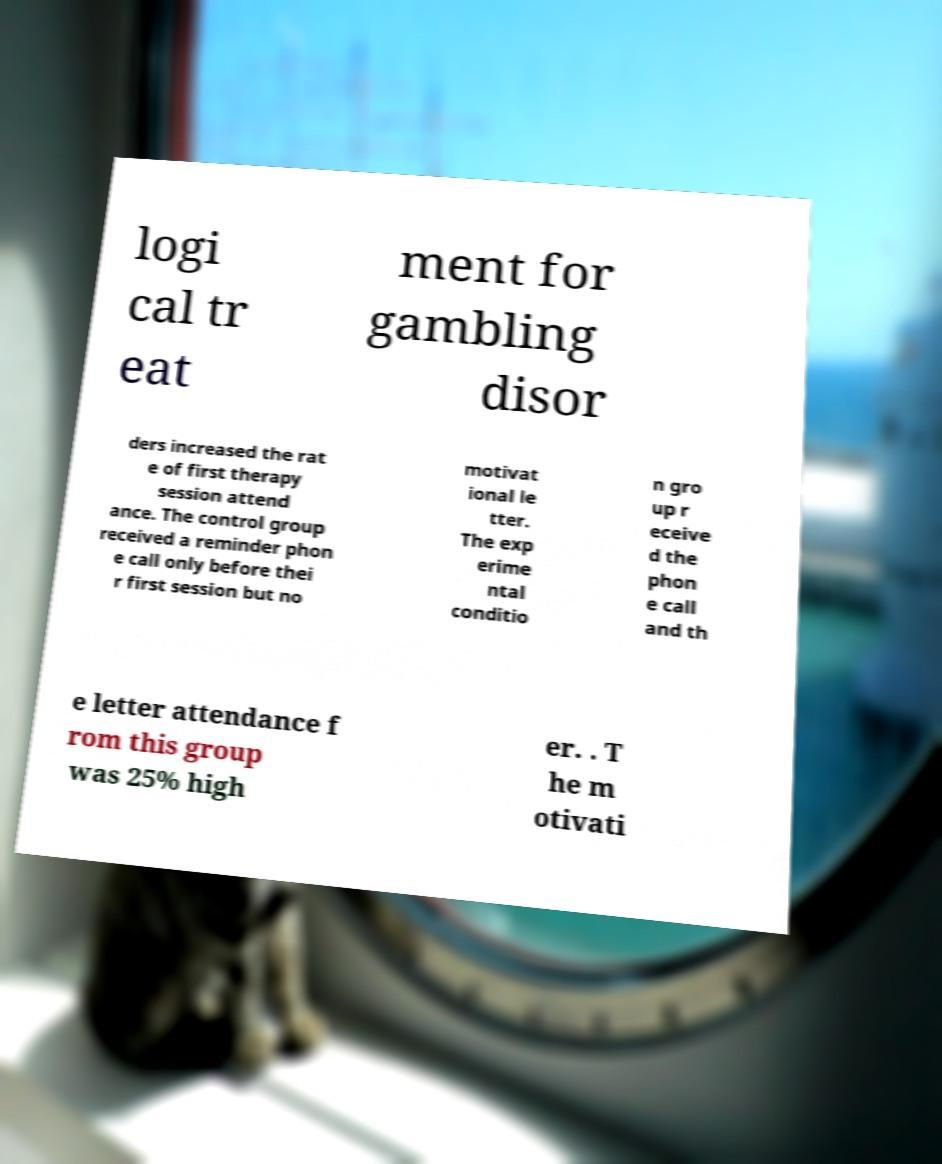Please read and relay the text visible in this image. What does it say? logi cal tr eat ment for gambling disor ders increased the rat e of first therapy session attend ance. The control group received a reminder phon e call only before thei r first session but no motivat ional le tter. The exp erime ntal conditio n gro up r eceive d the phon e call and th e letter attendance f rom this group was 25% high er. . T he m otivati 